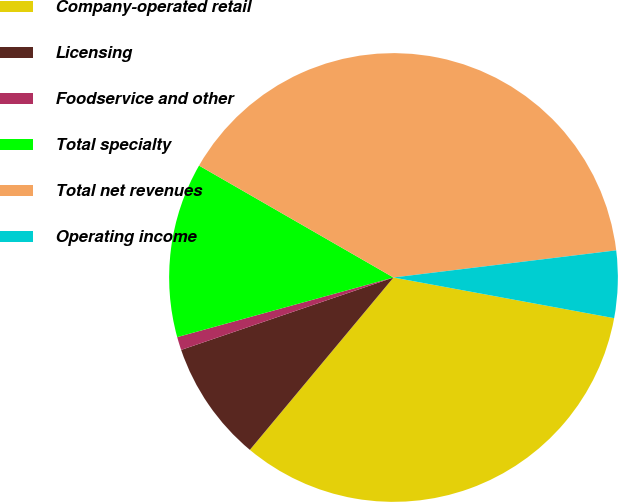<chart> <loc_0><loc_0><loc_500><loc_500><pie_chart><fcel>Company-operated retail<fcel>Licensing<fcel>Foodservice and other<fcel>Total specialty<fcel>Total net revenues<fcel>Operating income<nl><fcel>33.15%<fcel>8.71%<fcel>0.95%<fcel>12.59%<fcel>39.75%<fcel>4.83%<nl></chart> 